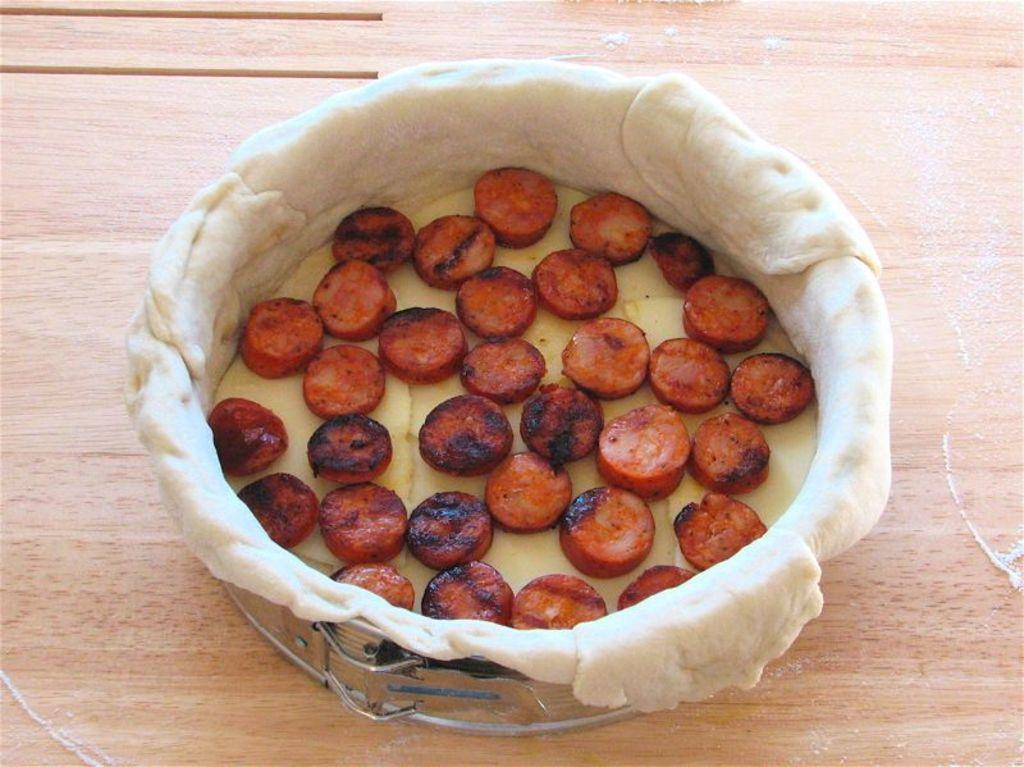What is the main subject of the image? There is a food item in the image. How is the food item contained or packaged? The food item is in a container. What type of surface is the container placed on? The container is placed on a wooden surface. What color is the linen used to wrap the food item in the image? There is no linen present in the image, and the food item is not wrapped. 